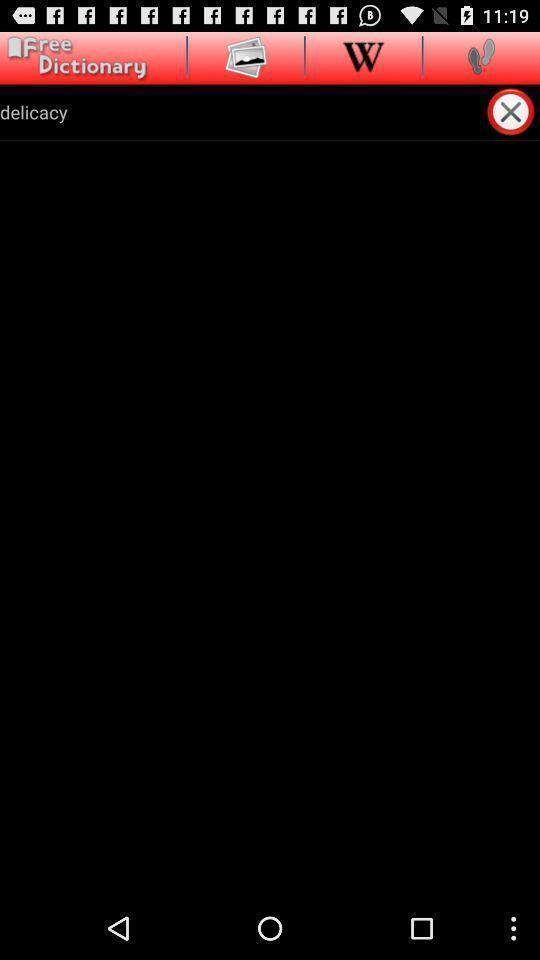Explain the elements present in this screenshot. Page shows the word delicacy on dictionary app. 